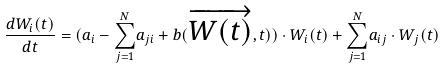<formula> <loc_0><loc_0><loc_500><loc_500>\frac { d W _ { i } ( t ) } { d t } = ( a _ { i } - { \sum _ { j = 1 } ^ { N } } a _ { j i } + b ( { \overrightarrow { W ( t ) } , t ) } ) \cdot W _ { i } ( t ) + { \sum _ { j = 1 } ^ { N } } a _ { i j } \cdot W _ { j } ( t )</formula> 